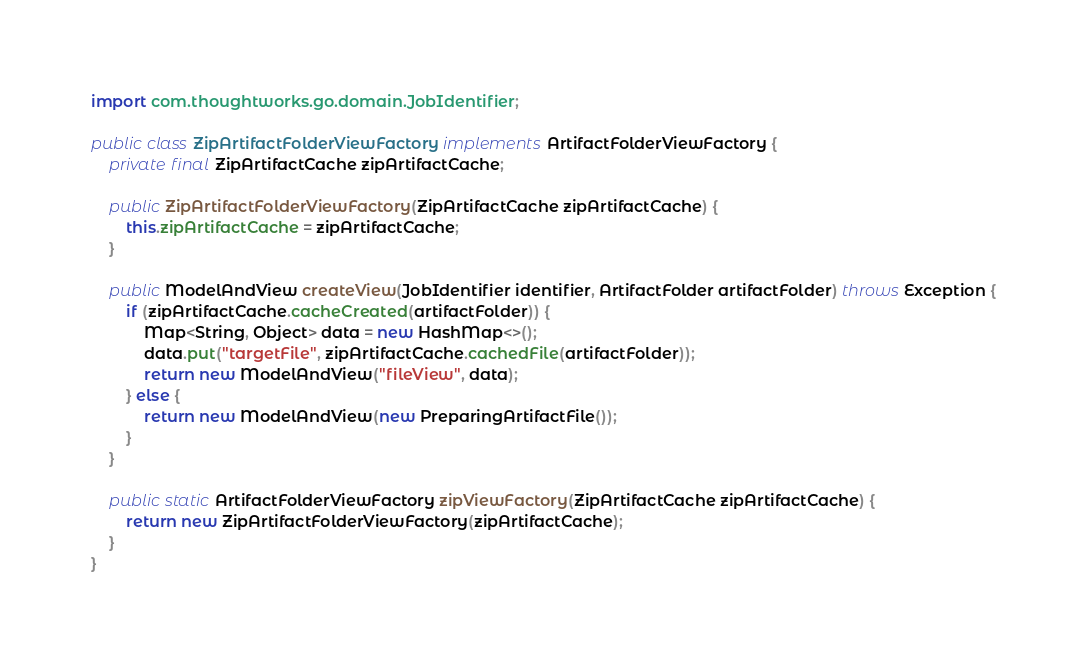<code> <loc_0><loc_0><loc_500><loc_500><_Java_>import com.thoughtworks.go.domain.JobIdentifier;

public class ZipArtifactFolderViewFactory implements ArtifactFolderViewFactory {
    private final ZipArtifactCache zipArtifactCache;

    public ZipArtifactFolderViewFactory(ZipArtifactCache zipArtifactCache) {
        this.zipArtifactCache = zipArtifactCache;
    }

    public ModelAndView createView(JobIdentifier identifier, ArtifactFolder artifactFolder) throws Exception {
        if (zipArtifactCache.cacheCreated(artifactFolder)) {
            Map<String, Object> data = new HashMap<>();
            data.put("targetFile", zipArtifactCache.cachedFile(artifactFolder));
            return new ModelAndView("fileView", data);
        } else {
            return new ModelAndView(new PreparingArtifactFile());
        }
    }

    public static ArtifactFolderViewFactory zipViewFactory(ZipArtifactCache zipArtifactCache) {
        return new ZipArtifactFolderViewFactory(zipArtifactCache);
    }
}
</code> 